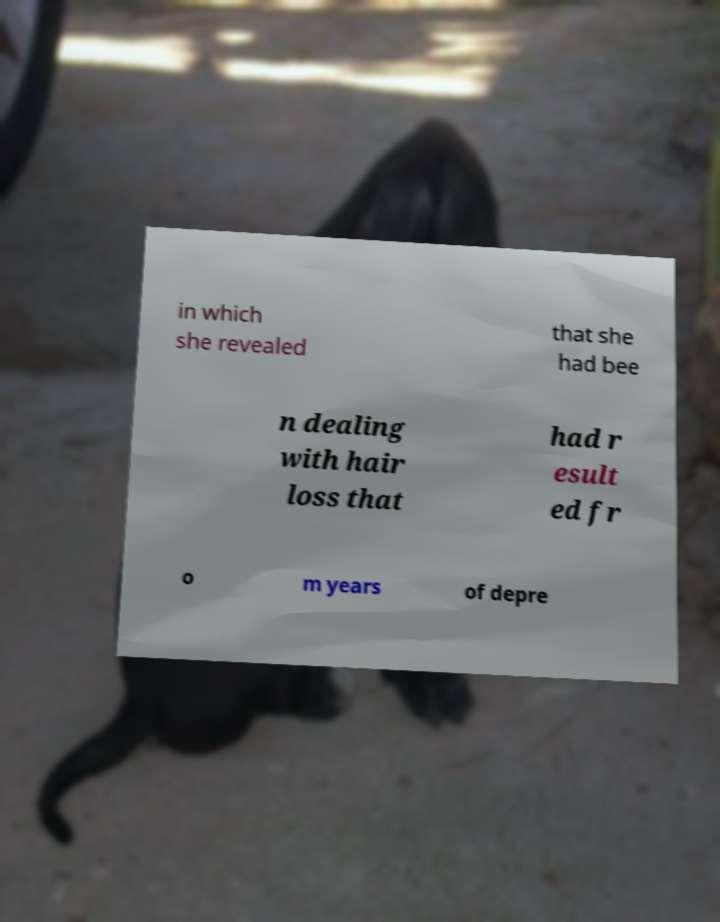Could you extract and type out the text from this image? in which she revealed that she had bee n dealing with hair loss that had r esult ed fr o m years of depre 